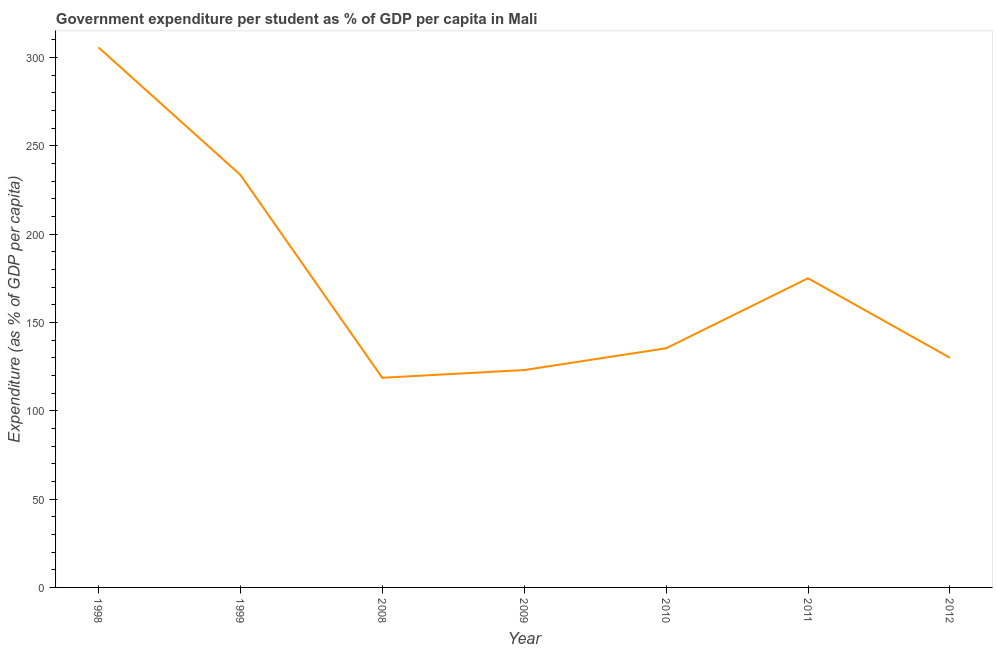What is the government expenditure per student in 2012?
Your response must be concise. 130.04. Across all years, what is the maximum government expenditure per student?
Offer a terse response. 305.79. Across all years, what is the minimum government expenditure per student?
Your response must be concise. 118.71. In which year was the government expenditure per student maximum?
Make the answer very short. 1998. In which year was the government expenditure per student minimum?
Make the answer very short. 2008. What is the sum of the government expenditure per student?
Provide a succinct answer. 1221.66. What is the difference between the government expenditure per student in 1999 and 2012?
Make the answer very short. 103.56. What is the average government expenditure per student per year?
Ensure brevity in your answer.  174.52. What is the median government expenditure per student?
Your answer should be compact. 135.4. In how many years, is the government expenditure per student greater than 90 %?
Provide a succinct answer. 7. Do a majority of the years between 2012 and 2008 (inclusive) have government expenditure per student greater than 220 %?
Give a very brief answer. Yes. What is the ratio of the government expenditure per student in 1998 to that in 1999?
Offer a very short reply. 1.31. What is the difference between the highest and the second highest government expenditure per student?
Provide a succinct answer. 72.19. Is the sum of the government expenditure per student in 1998 and 1999 greater than the maximum government expenditure per student across all years?
Make the answer very short. Yes. What is the difference between the highest and the lowest government expenditure per student?
Ensure brevity in your answer.  187.08. In how many years, is the government expenditure per student greater than the average government expenditure per student taken over all years?
Your response must be concise. 3. How many lines are there?
Ensure brevity in your answer.  1. How many years are there in the graph?
Provide a short and direct response. 7. Are the values on the major ticks of Y-axis written in scientific E-notation?
Offer a terse response. No. Does the graph contain any zero values?
Offer a terse response. No. What is the title of the graph?
Offer a very short reply. Government expenditure per student as % of GDP per capita in Mali. What is the label or title of the Y-axis?
Your response must be concise. Expenditure (as % of GDP per capita). What is the Expenditure (as % of GDP per capita) in 1998?
Ensure brevity in your answer.  305.79. What is the Expenditure (as % of GDP per capita) in 1999?
Your response must be concise. 233.6. What is the Expenditure (as % of GDP per capita) in 2008?
Your response must be concise. 118.71. What is the Expenditure (as % of GDP per capita) in 2009?
Your response must be concise. 123.07. What is the Expenditure (as % of GDP per capita) in 2010?
Make the answer very short. 135.4. What is the Expenditure (as % of GDP per capita) of 2011?
Provide a short and direct response. 175.04. What is the Expenditure (as % of GDP per capita) of 2012?
Offer a very short reply. 130.04. What is the difference between the Expenditure (as % of GDP per capita) in 1998 and 1999?
Make the answer very short. 72.19. What is the difference between the Expenditure (as % of GDP per capita) in 1998 and 2008?
Keep it short and to the point. 187.08. What is the difference between the Expenditure (as % of GDP per capita) in 1998 and 2009?
Ensure brevity in your answer.  182.72. What is the difference between the Expenditure (as % of GDP per capita) in 1998 and 2010?
Your answer should be very brief. 170.38. What is the difference between the Expenditure (as % of GDP per capita) in 1998 and 2011?
Ensure brevity in your answer.  130.74. What is the difference between the Expenditure (as % of GDP per capita) in 1998 and 2012?
Provide a succinct answer. 175.75. What is the difference between the Expenditure (as % of GDP per capita) in 1999 and 2008?
Give a very brief answer. 114.89. What is the difference between the Expenditure (as % of GDP per capita) in 1999 and 2009?
Your answer should be compact. 110.53. What is the difference between the Expenditure (as % of GDP per capita) in 1999 and 2010?
Make the answer very short. 98.2. What is the difference between the Expenditure (as % of GDP per capita) in 1999 and 2011?
Your answer should be compact. 58.56. What is the difference between the Expenditure (as % of GDP per capita) in 1999 and 2012?
Your response must be concise. 103.56. What is the difference between the Expenditure (as % of GDP per capita) in 2008 and 2009?
Ensure brevity in your answer.  -4.36. What is the difference between the Expenditure (as % of GDP per capita) in 2008 and 2010?
Offer a terse response. -16.69. What is the difference between the Expenditure (as % of GDP per capita) in 2008 and 2011?
Offer a terse response. -56.33. What is the difference between the Expenditure (as % of GDP per capita) in 2008 and 2012?
Your response must be concise. -11.33. What is the difference between the Expenditure (as % of GDP per capita) in 2009 and 2010?
Make the answer very short. -12.33. What is the difference between the Expenditure (as % of GDP per capita) in 2009 and 2011?
Your answer should be very brief. -51.97. What is the difference between the Expenditure (as % of GDP per capita) in 2009 and 2012?
Offer a terse response. -6.97. What is the difference between the Expenditure (as % of GDP per capita) in 2010 and 2011?
Offer a terse response. -39.64. What is the difference between the Expenditure (as % of GDP per capita) in 2010 and 2012?
Offer a terse response. 5.36. What is the difference between the Expenditure (as % of GDP per capita) in 2011 and 2012?
Give a very brief answer. 45. What is the ratio of the Expenditure (as % of GDP per capita) in 1998 to that in 1999?
Offer a very short reply. 1.31. What is the ratio of the Expenditure (as % of GDP per capita) in 1998 to that in 2008?
Keep it short and to the point. 2.58. What is the ratio of the Expenditure (as % of GDP per capita) in 1998 to that in 2009?
Your answer should be very brief. 2.48. What is the ratio of the Expenditure (as % of GDP per capita) in 1998 to that in 2010?
Provide a succinct answer. 2.26. What is the ratio of the Expenditure (as % of GDP per capita) in 1998 to that in 2011?
Provide a succinct answer. 1.75. What is the ratio of the Expenditure (as % of GDP per capita) in 1998 to that in 2012?
Your response must be concise. 2.35. What is the ratio of the Expenditure (as % of GDP per capita) in 1999 to that in 2008?
Ensure brevity in your answer.  1.97. What is the ratio of the Expenditure (as % of GDP per capita) in 1999 to that in 2009?
Your answer should be compact. 1.9. What is the ratio of the Expenditure (as % of GDP per capita) in 1999 to that in 2010?
Give a very brief answer. 1.73. What is the ratio of the Expenditure (as % of GDP per capita) in 1999 to that in 2011?
Offer a very short reply. 1.33. What is the ratio of the Expenditure (as % of GDP per capita) in 1999 to that in 2012?
Offer a very short reply. 1.8. What is the ratio of the Expenditure (as % of GDP per capita) in 2008 to that in 2009?
Make the answer very short. 0.96. What is the ratio of the Expenditure (as % of GDP per capita) in 2008 to that in 2010?
Your answer should be very brief. 0.88. What is the ratio of the Expenditure (as % of GDP per capita) in 2008 to that in 2011?
Keep it short and to the point. 0.68. What is the ratio of the Expenditure (as % of GDP per capita) in 2009 to that in 2010?
Offer a very short reply. 0.91. What is the ratio of the Expenditure (as % of GDP per capita) in 2009 to that in 2011?
Keep it short and to the point. 0.7. What is the ratio of the Expenditure (as % of GDP per capita) in 2009 to that in 2012?
Make the answer very short. 0.95. What is the ratio of the Expenditure (as % of GDP per capita) in 2010 to that in 2011?
Ensure brevity in your answer.  0.77. What is the ratio of the Expenditure (as % of GDP per capita) in 2010 to that in 2012?
Ensure brevity in your answer.  1.04. What is the ratio of the Expenditure (as % of GDP per capita) in 2011 to that in 2012?
Offer a very short reply. 1.35. 